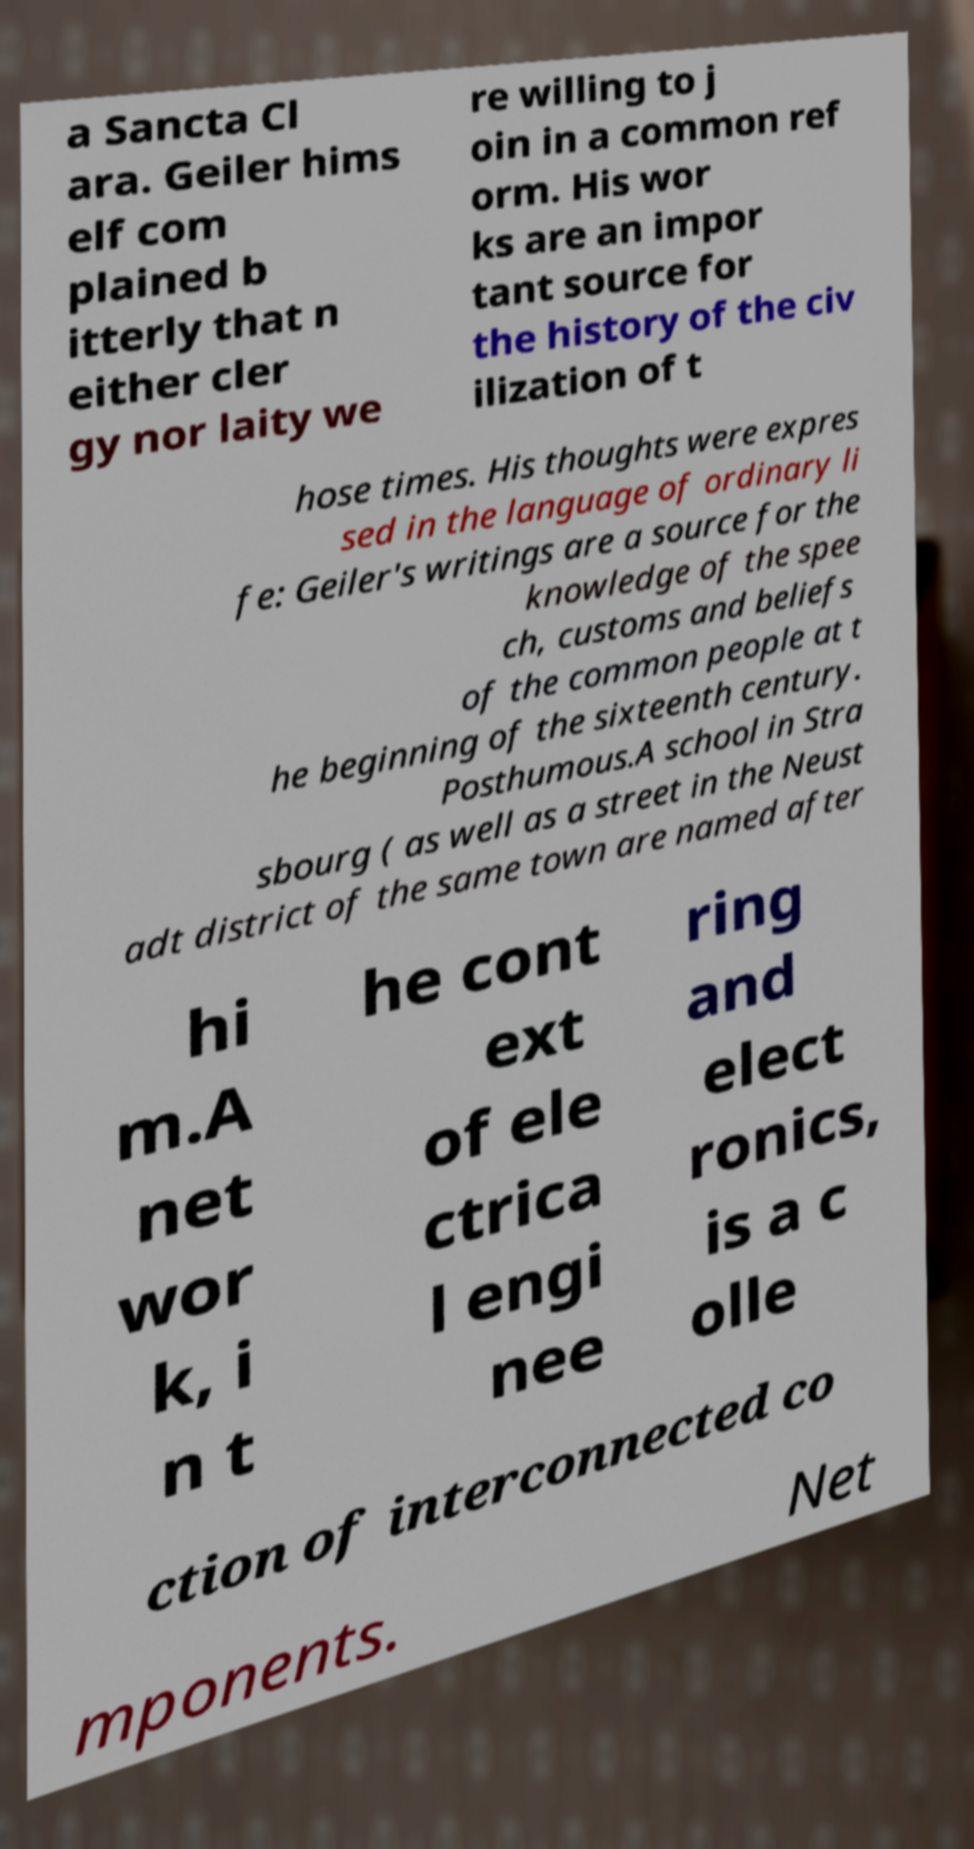Could you assist in decoding the text presented in this image and type it out clearly? a Sancta Cl ara. Geiler hims elf com plained b itterly that n either cler gy nor laity we re willing to j oin in a common ref orm. His wor ks are an impor tant source for the history of the civ ilization of t hose times. His thoughts were expres sed in the language of ordinary li fe: Geiler's writings are a source for the knowledge of the spee ch, customs and beliefs of the common people at t he beginning of the sixteenth century. Posthumous.A school in Stra sbourg ( as well as a street in the Neust adt district of the same town are named after hi m.A net wor k, i n t he cont ext of ele ctrica l engi nee ring and elect ronics, is a c olle ction of interconnected co mponents. Net 